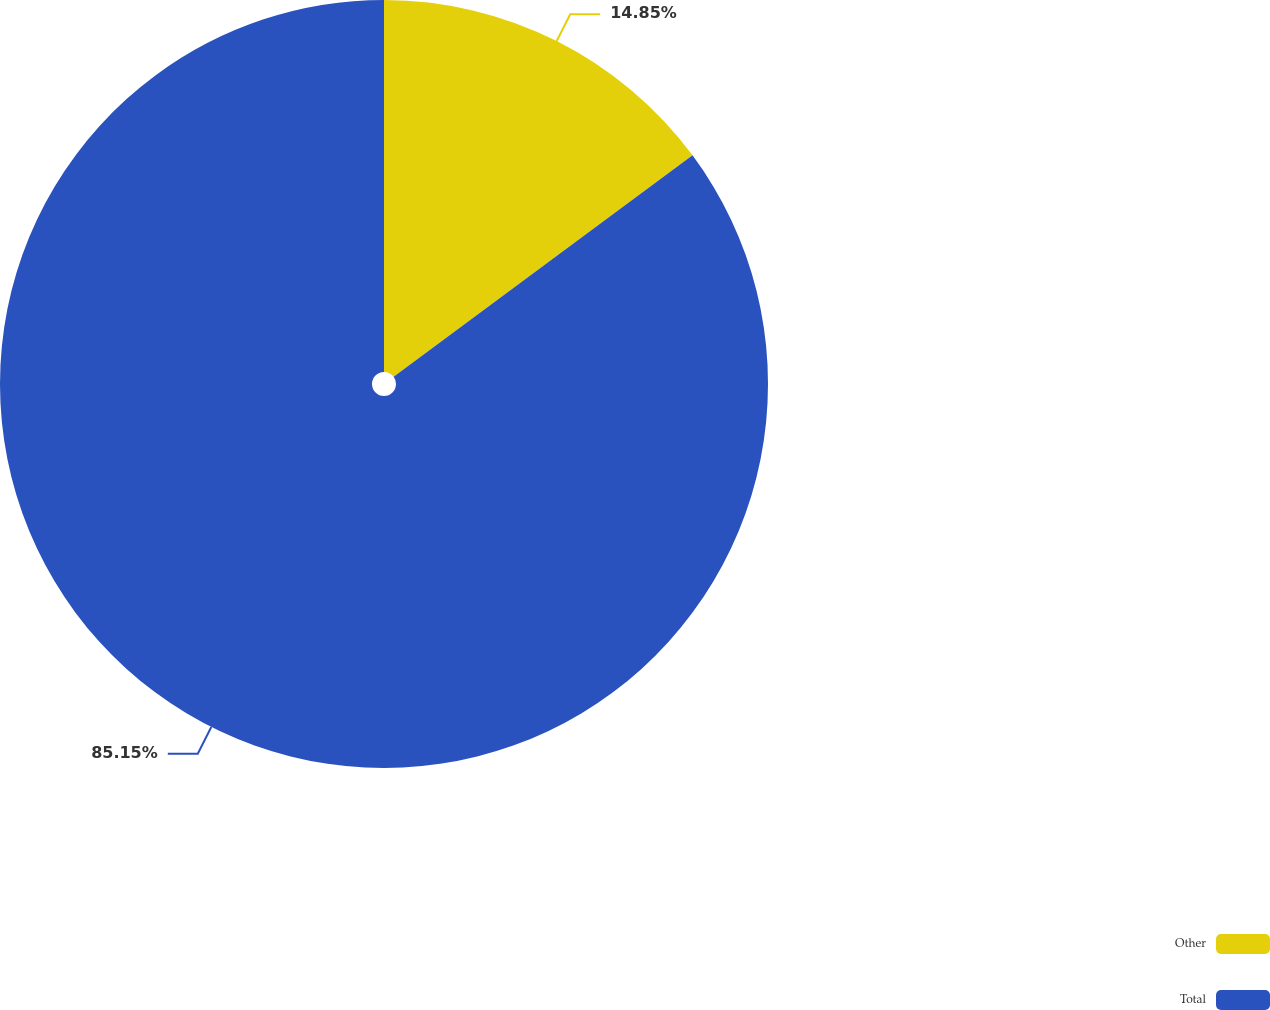<chart> <loc_0><loc_0><loc_500><loc_500><pie_chart><fcel>Other<fcel>Total<nl><fcel>14.85%<fcel>85.15%<nl></chart> 